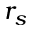Convert formula to latex. <formula><loc_0><loc_0><loc_500><loc_500>r _ { s }</formula> 